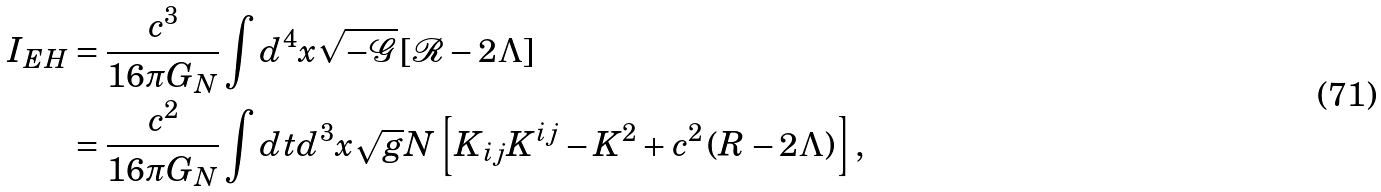<formula> <loc_0><loc_0><loc_500><loc_500>I _ { E H } & = \frac { c ^ { 3 } } { 1 6 \pi G _ { N } } \int d ^ { 4 } x \sqrt { - \mathcal { G } } \left [ \mathcal { R } - 2 \Lambda \right ] \\ & = \frac { c ^ { 2 } } { 1 6 \pi G _ { N } } \int d t d ^ { 3 } x \sqrt { g } N \left [ K _ { i j } K ^ { i j } - K ^ { 2 } + c ^ { 2 } \left ( R - 2 \Lambda \right ) \right ] ,</formula> 